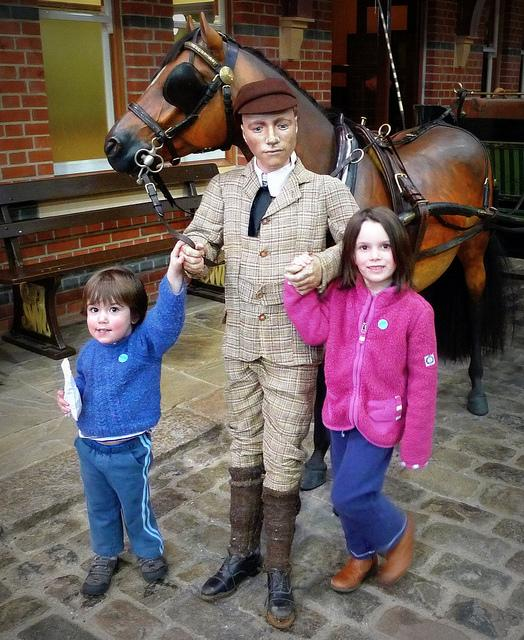What type of material makes up a majority of the construction in the area? Please explain your reasoning. stone. Looks like brick or stone is on the ground. 